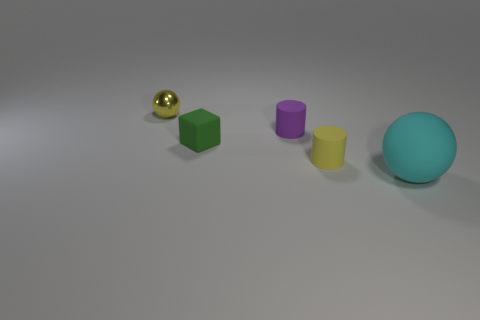Add 1 small spheres. How many objects exist? 6 Subtract all cubes. How many objects are left? 4 Subtract all purple matte objects. Subtract all tiny rubber things. How many objects are left? 1 Add 2 large cyan spheres. How many large cyan spheres are left? 3 Add 4 yellow matte objects. How many yellow matte objects exist? 5 Subtract 0 green balls. How many objects are left? 5 